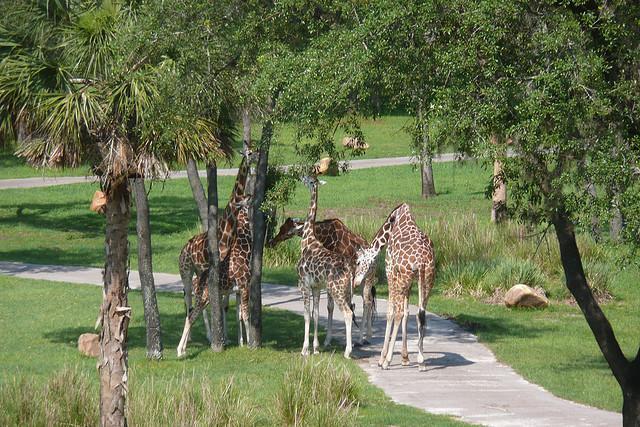Where are these animals most likely to be found in their natural habitat?
Answer the question by selecting the correct answer among the 4 following choices.
Options: Russia, new brunswick, new york, africa. Africa. What are the giraffes playing around?
Select the accurate response from the four choices given to answer the question.
Options: Babies, cars, coyotes, trees. Trees. 